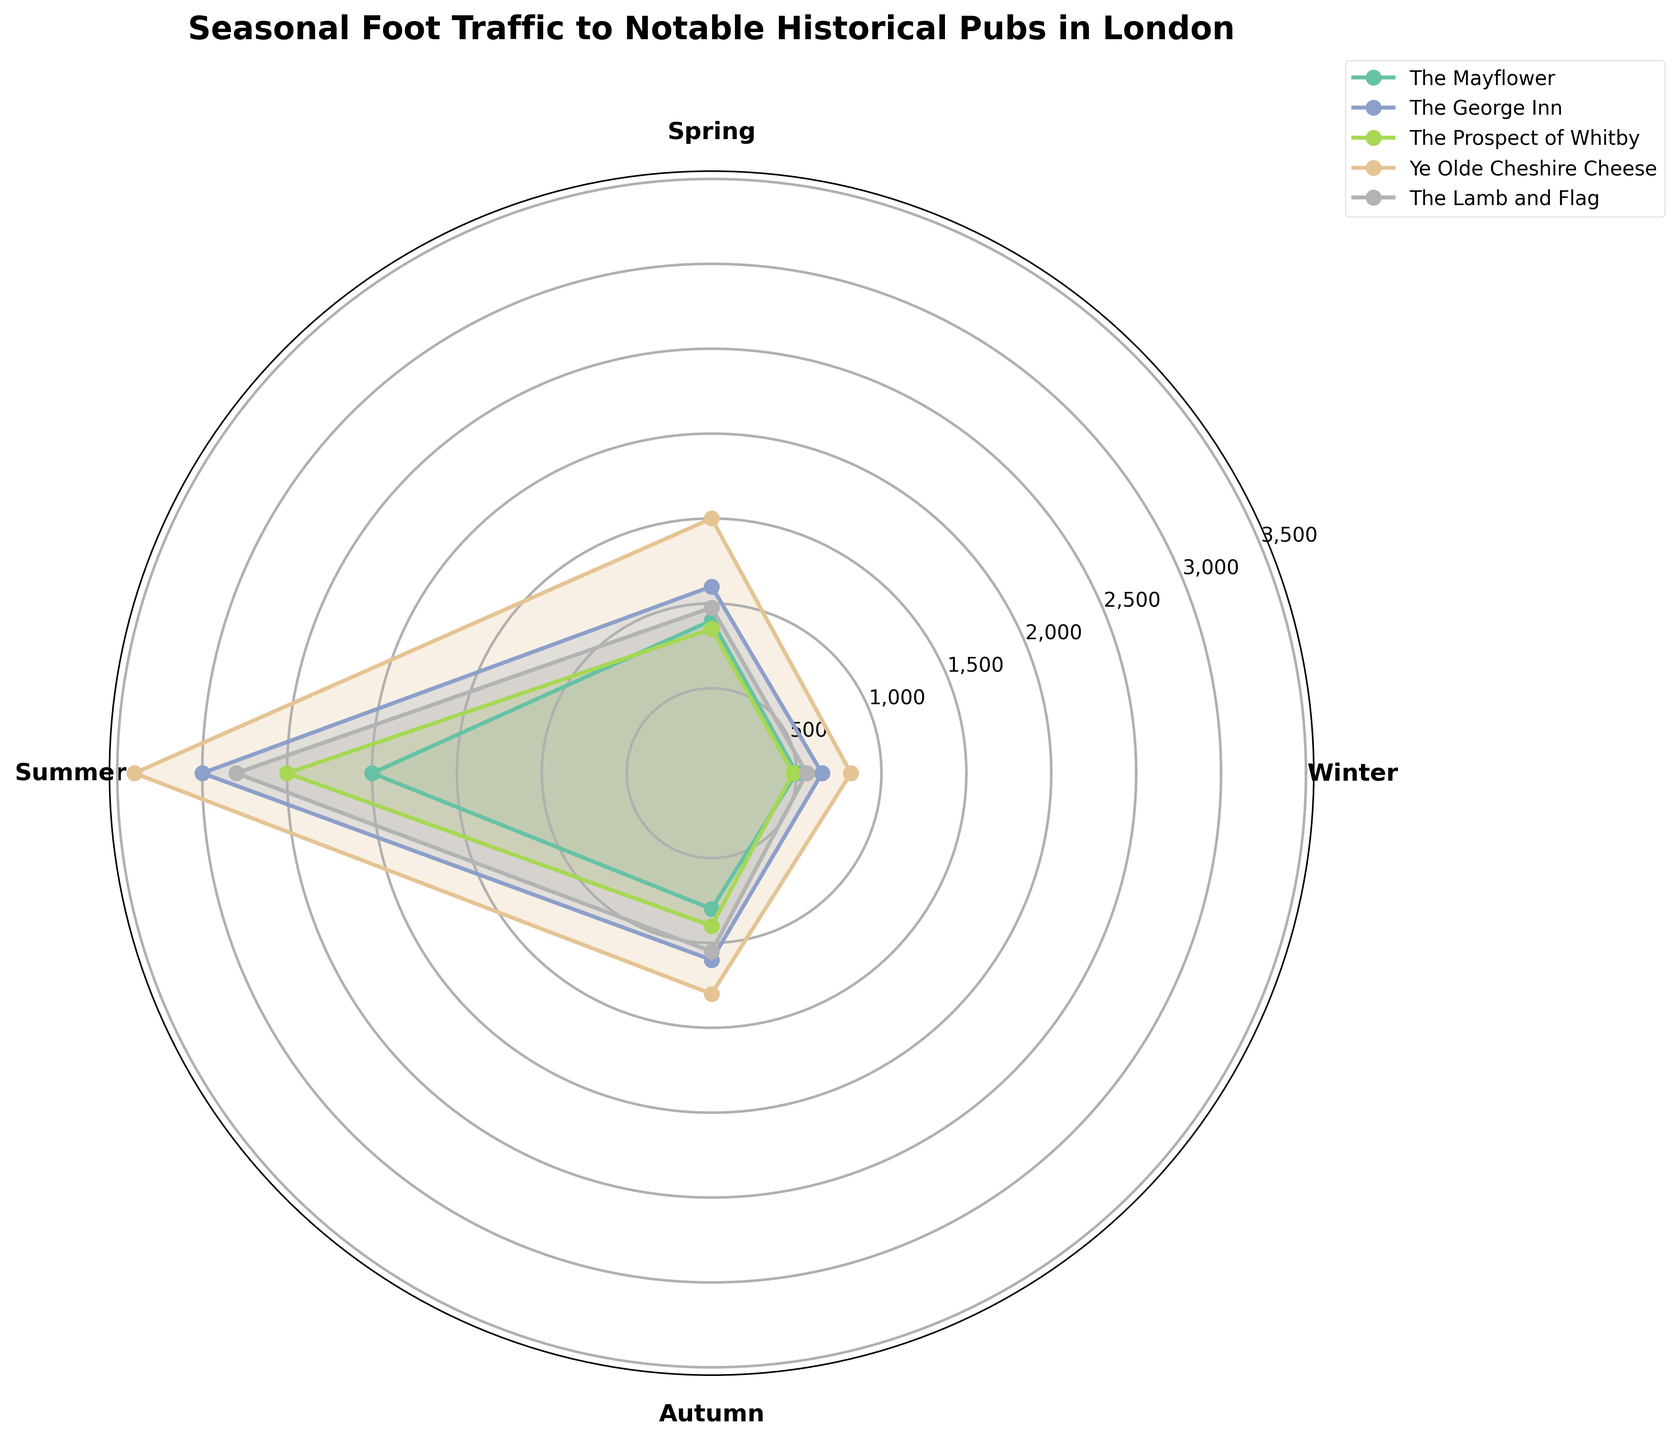What's the title of the rose chart? The title is usually found at the top of a chart. It provides a brief summary of what the chart represents. In this case, the title is "Seasonal Foot Traffic to Notable Historical Pubs in London".
Answer: Seasonal Foot Traffic to Notable Historical Pubs in London Which season has the highest foot traffic for 'Ye Olde Cheshire Cheese'? Find the line and fill areas representing 'Ye Olde Cheshire Cheese' across seasons and locate the highest point. The 'Ye Olde Cheshire Cheese' sees its peak tourist numbers in Summer.
Answer: Summer What is the total foot traffic for 'The George Inn' across all seasons? Add up the tourist numbers for 'The George Inn' in Winter, Spring, Summer, and Autumn: 650 + 1100 + 3000 + 1100 = 5850.
Answer: 5850 How does the foot traffic in Winter compare to Spring for 'The Mayflower'? Compare the length of the 'The Mayflower' data points on the radial scale for Winter (500) and Spring (900). Spring has higher foot traffic than Winter.
Answer: Spring is higher Which pub has the lowest foot traffic in Autumn? Identify the pub with the smallest radial distance in Autumn. 'The Mayflower' has the lowest foot traffic (800) among the pubs in Autumn.
Answer: The Mayflower What is the average foot traffic for 'The Lamb and Flag' across all seasons? Sum the foot traffic numbers for 'The Lamb and Flag' across the four seasons: 560 + 975 + 2800 + 1050 = 5385. Divide by the number of seasons (4): 5385 / 4 = 1346.25.
Answer: 1346.25 Is the foot traffic in Summer higher than Autumn for 'The Prospect of Whitby'? Compare the radial lengths for Summer (2500) and Autumn (900) for 'The Prospect of Whitby'. Summer has higher foot traffic than Autumn.
Answer: Yes Which season shows the largest increase in foot traffic for 'The George Inn' compared to the previous season? Calculate the differences between consecutive seasons for 'The George Inn': Winter to Spring (1100 - 650 = 450), Spring to Summer (3000 - 1100 = 1900), Summer to Autumn (1100 - 3000 = -1900). The largest increase is from Spring to Summer.
Answer: Spring to Summer 